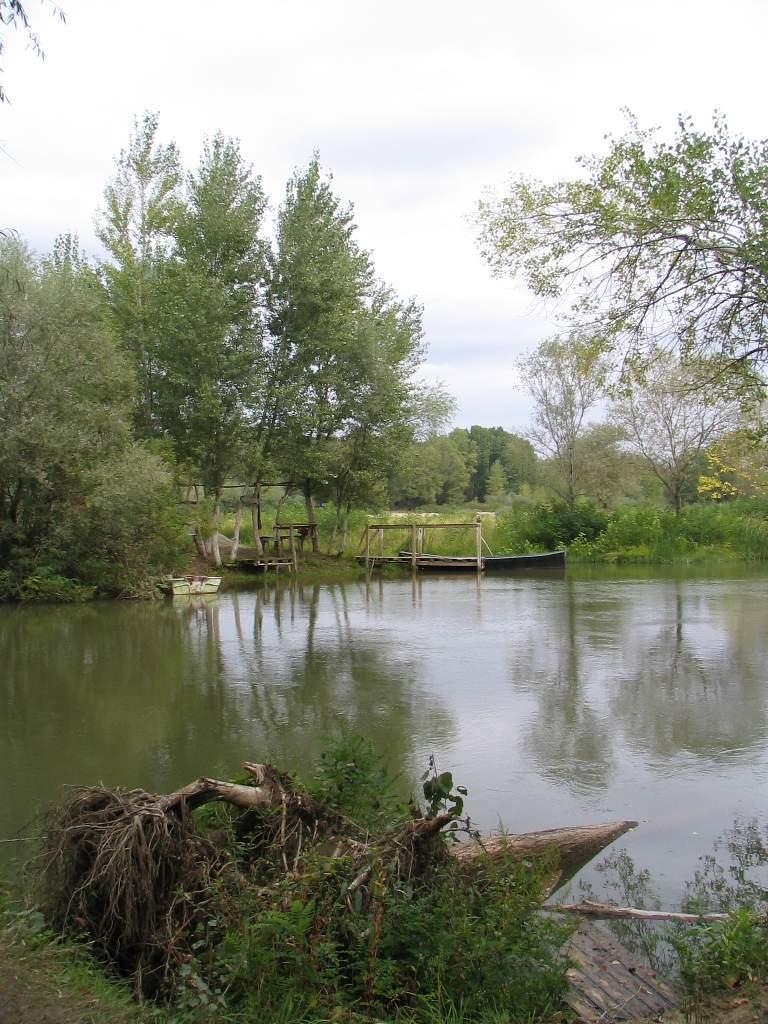What type of vegetation can be seen in the image? There are trees and plants in the image. What is the primary body of water in the image? There is water visible in the image. What type of vehicle is present in the image? There is a boat in the image. What material are the logs made of in the image? The wooden logs in the image are made of wood. What is visible at the top of the image? The sky is visible at the top of the image. How many cows are present in the image? There are no cows present in the image. What type of pain is the writer experiencing in the image? There is no writer or pain present in the image. 